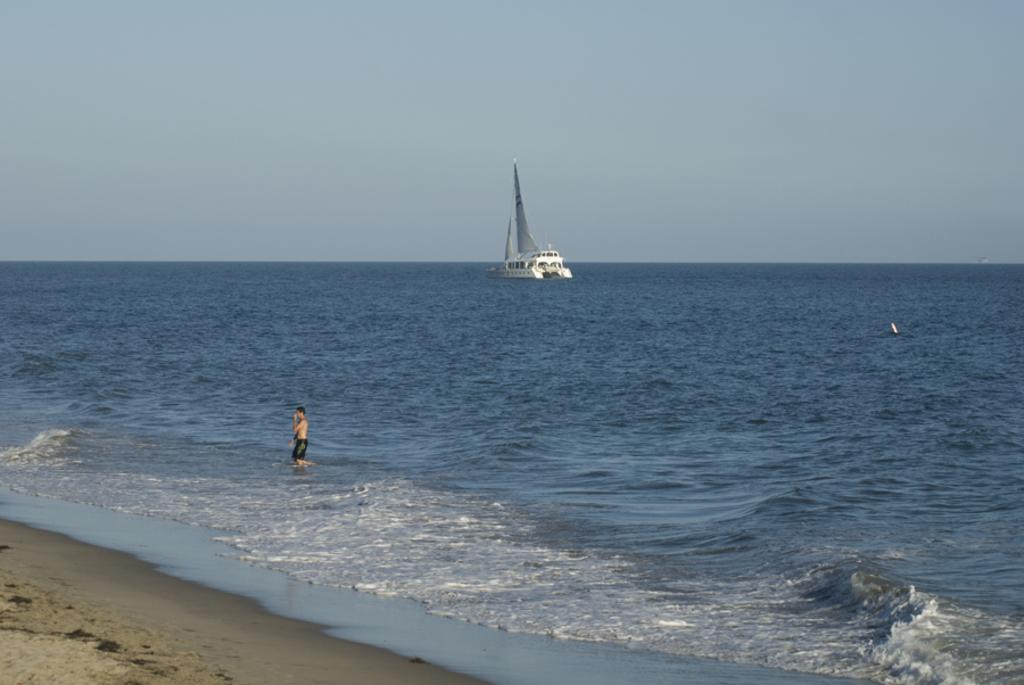Who is present in the image? There is a man in the image. What is the main object in the image? There is a ship above the water in the image. What type of terrain is visible in the image? There is sand visible in the image. What can be seen in the background of the image? The sky is visible in the background of the image. What type of art is the man giving advice on in the image? There is no art or advice-giving activity present in the image; it features a man and a ship above the water. 